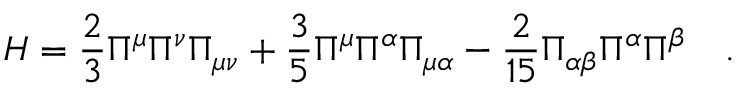<formula> <loc_0><loc_0><loc_500><loc_500>H = \frac { 2 } { 3 } \Pi ^ { \mu } \Pi ^ { \nu } \Pi _ { \mu \nu } + \frac { 3 } { 5 } \Pi ^ { \mu } \Pi ^ { \alpha } \Pi _ { \mu \alpha } - \frac { 2 } { 1 5 } \Pi _ { \alpha \beta } \Pi ^ { \alpha } \Pi ^ { \beta } \quad .</formula> 